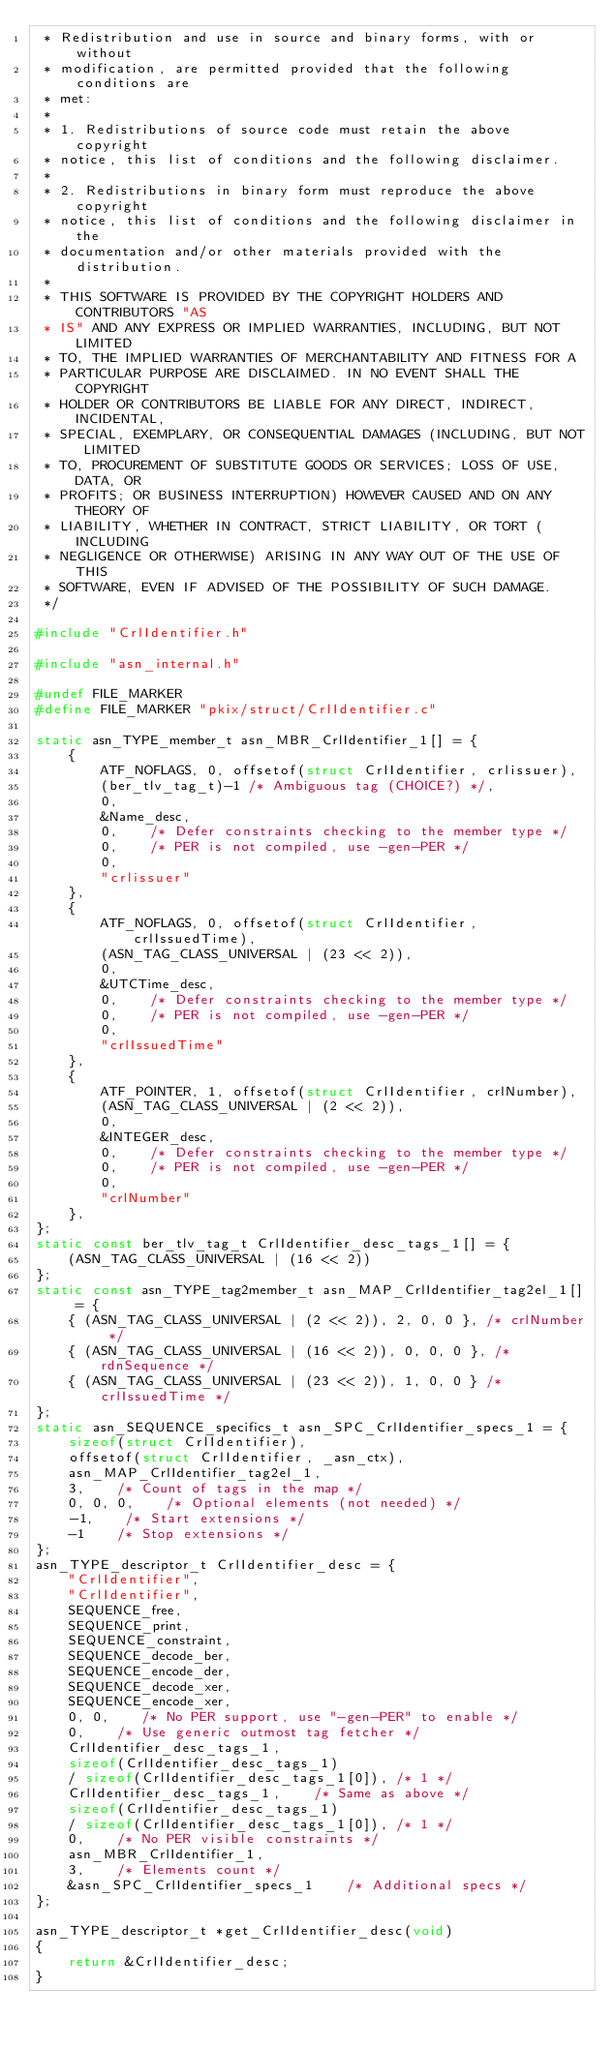<code> <loc_0><loc_0><loc_500><loc_500><_C_> * Redistribution and use in source and binary forms, with or without 
 * modification, are permitted provided that the following conditions are 
 * met:
 * 
 * 1. Redistributions of source code must retain the above copyright 
 * notice, this list of conditions and the following disclaimer.
 * 
 * 2. Redistributions in binary form must reproduce the above copyright 
 * notice, this list of conditions and the following disclaimer in the 
 * documentation and/or other materials provided with the distribution.
 * 
 * THIS SOFTWARE IS PROVIDED BY THE COPYRIGHT HOLDERS AND CONTRIBUTORS "AS 
 * IS" AND ANY EXPRESS OR IMPLIED WARRANTIES, INCLUDING, BUT NOT LIMITED 
 * TO, THE IMPLIED WARRANTIES OF MERCHANTABILITY AND FITNESS FOR A 
 * PARTICULAR PURPOSE ARE DISCLAIMED. IN NO EVENT SHALL THE COPYRIGHT 
 * HOLDER OR CONTRIBUTORS BE LIABLE FOR ANY DIRECT, INDIRECT, INCIDENTAL, 
 * SPECIAL, EXEMPLARY, OR CONSEQUENTIAL DAMAGES (INCLUDING, BUT NOT LIMITED 
 * TO, PROCUREMENT OF SUBSTITUTE GOODS OR SERVICES; LOSS OF USE, DATA, OR 
 * PROFITS; OR BUSINESS INTERRUPTION) HOWEVER CAUSED AND ON ANY THEORY OF 
 * LIABILITY, WHETHER IN CONTRACT, STRICT LIABILITY, OR TORT (INCLUDING 
 * NEGLIGENCE OR OTHERWISE) ARISING IN ANY WAY OUT OF THE USE OF THIS 
 * SOFTWARE, EVEN IF ADVISED OF THE POSSIBILITY OF SUCH DAMAGE.
 */

#include "CrlIdentifier.h"

#include "asn_internal.h"

#undef FILE_MARKER
#define FILE_MARKER "pkix/struct/CrlIdentifier.c"

static asn_TYPE_member_t asn_MBR_CrlIdentifier_1[] = {
    {
        ATF_NOFLAGS, 0, offsetof(struct CrlIdentifier, crlissuer),
        (ber_tlv_tag_t)-1 /* Ambiguous tag (CHOICE?) */,
        0,
        &Name_desc,
        0,    /* Defer constraints checking to the member type */
        0,    /* PER is not compiled, use -gen-PER */
        0,
        "crlissuer"
    },
    {
        ATF_NOFLAGS, 0, offsetof(struct CrlIdentifier, crlIssuedTime),
        (ASN_TAG_CLASS_UNIVERSAL | (23 << 2)),
        0,
        &UTCTime_desc,
        0,    /* Defer constraints checking to the member type */
        0,    /* PER is not compiled, use -gen-PER */
        0,
        "crlIssuedTime"
    },
    {
        ATF_POINTER, 1, offsetof(struct CrlIdentifier, crlNumber),
        (ASN_TAG_CLASS_UNIVERSAL | (2 << 2)),
        0,
        &INTEGER_desc,
        0,    /* Defer constraints checking to the member type */
        0,    /* PER is not compiled, use -gen-PER */
        0,
        "crlNumber"
    },
};
static const ber_tlv_tag_t CrlIdentifier_desc_tags_1[] = {
    (ASN_TAG_CLASS_UNIVERSAL | (16 << 2))
};
static const asn_TYPE_tag2member_t asn_MAP_CrlIdentifier_tag2el_1[] = {
    { (ASN_TAG_CLASS_UNIVERSAL | (2 << 2)), 2, 0, 0 }, /* crlNumber */
    { (ASN_TAG_CLASS_UNIVERSAL | (16 << 2)), 0, 0, 0 }, /* rdnSequence */
    { (ASN_TAG_CLASS_UNIVERSAL | (23 << 2)), 1, 0, 0 } /* crlIssuedTime */
};
static asn_SEQUENCE_specifics_t asn_SPC_CrlIdentifier_specs_1 = {
    sizeof(struct CrlIdentifier),
    offsetof(struct CrlIdentifier, _asn_ctx),
    asn_MAP_CrlIdentifier_tag2el_1,
    3,    /* Count of tags in the map */
    0, 0, 0,    /* Optional elements (not needed) */
    -1,    /* Start extensions */
    -1    /* Stop extensions */
};
asn_TYPE_descriptor_t CrlIdentifier_desc = {
    "CrlIdentifier",
    "CrlIdentifier",
    SEQUENCE_free,
    SEQUENCE_print,
    SEQUENCE_constraint,
    SEQUENCE_decode_ber,
    SEQUENCE_encode_der,
    SEQUENCE_decode_xer,
    SEQUENCE_encode_xer,
    0, 0,    /* No PER support, use "-gen-PER" to enable */
    0,    /* Use generic outmost tag fetcher */
    CrlIdentifier_desc_tags_1,
    sizeof(CrlIdentifier_desc_tags_1)
    / sizeof(CrlIdentifier_desc_tags_1[0]), /* 1 */
    CrlIdentifier_desc_tags_1,    /* Same as above */
    sizeof(CrlIdentifier_desc_tags_1)
    / sizeof(CrlIdentifier_desc_tags_1[0]), /* 1 */
    0,    /* No PER visible constraints */
    asn_MBR_CrlIdentifier_1,
    3,    /* Elements count */
    &asn_SPC_CrlIdentifier_specs_1    /* Additional specs */
};

asn_TYPE_descriptor_t *get_CrlIdentifier_desc(void)
{
    return &CrlIdentifier_desc;
}
</code> 